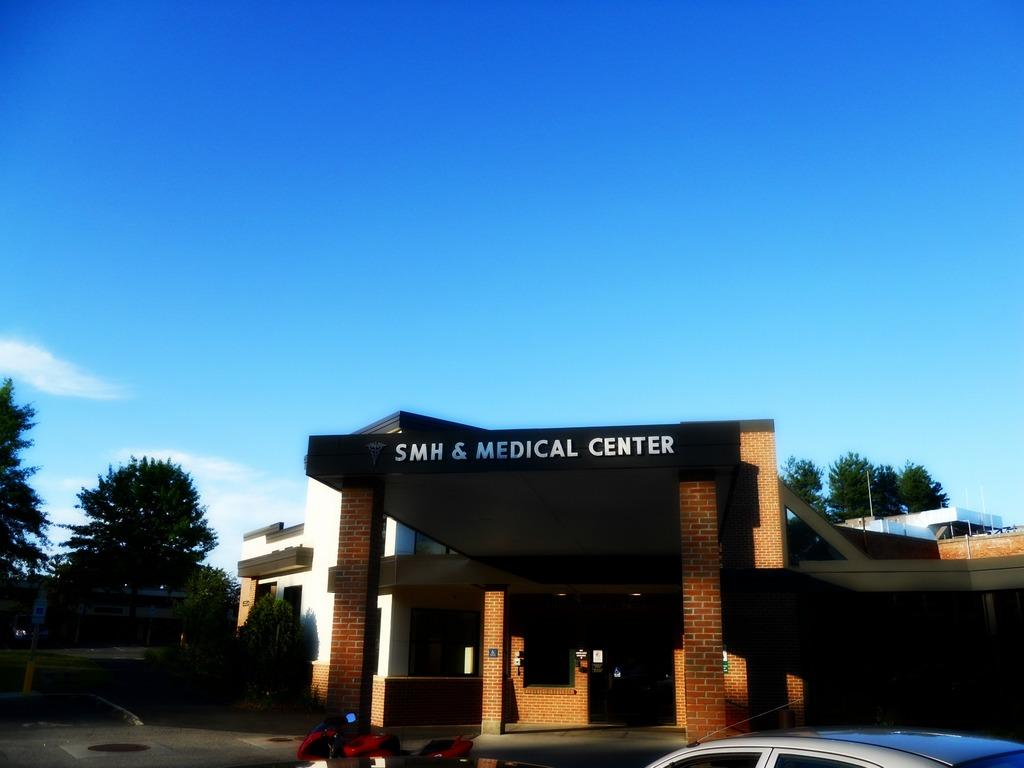What is the color of the sky in the image? The sky in the image is clear and blue. What vehicles are parked in the image? A motorbike and a car are parked in the image. What type of vegetation is present in the image? There are many trees in the image. What color is the polish on the motorbike's toe in the image? There is no motorbike with a toe or polish present in the image. 